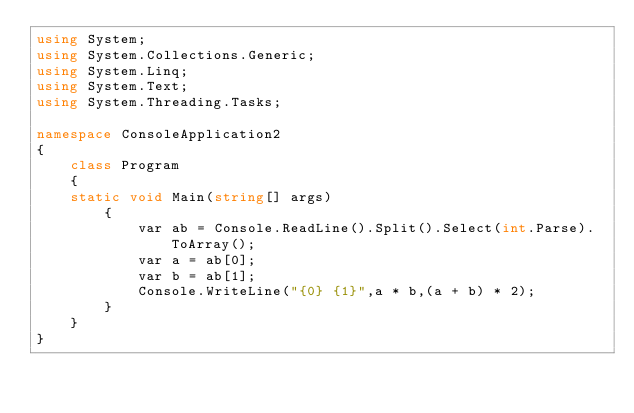<code> <loc_0><loc_0><loc_500><loc_500><_C#_>using System;
using System.Collections.Generic;
using System.Linq;
using System.Text;
using System.Threading.Tasks;

namespace ConsoleApplication2
{ 
    class Program
    {
    static void Main(string[] args)
        {
            var ab = Console.ReadLine().Split().Select(int.Parse).ToArray();
            var a = ab[0];
            var b = ab[1];
            Console.WriteLine("{0} {1}",a * b,(a + b) * 2);
        }
    }
}</code> 